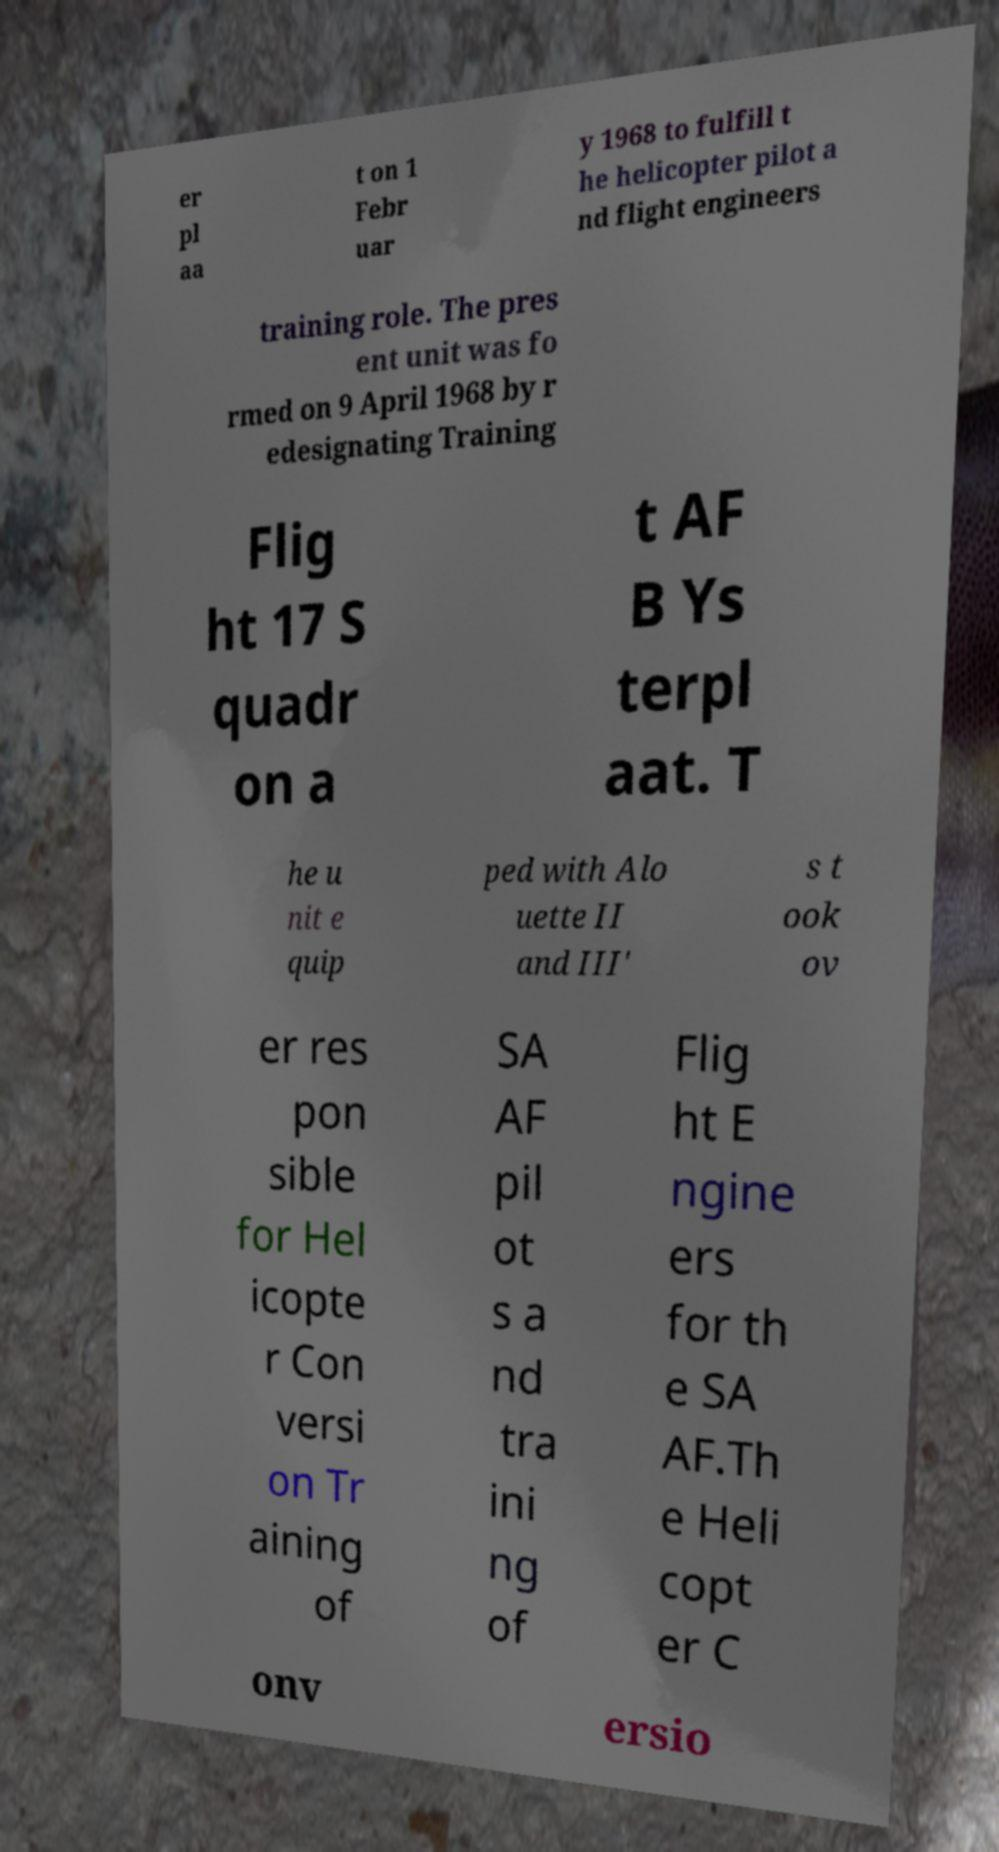What messages or text are displayed in this image? I need them in a readable, typed format. er pl aa t on 1 Febr uar y 1968 to fulfill t he helicopter pilot a nd flight engineers training role. The pres ent unit was fo rmed on 9 April 1968 by r edesignating Training Flig ht 17 S quadr on a t AF B Ys terpl aat. T he u nit e quip ped with Alo uette II and III' s t ook ov er res pon sible for Hel icopte r Con versi on Tr aining of SA AF pil ot s a nd tra ini ng of Flig ht E ngine ers for th e SA AF.Th e Heli copt er C onv ersio 